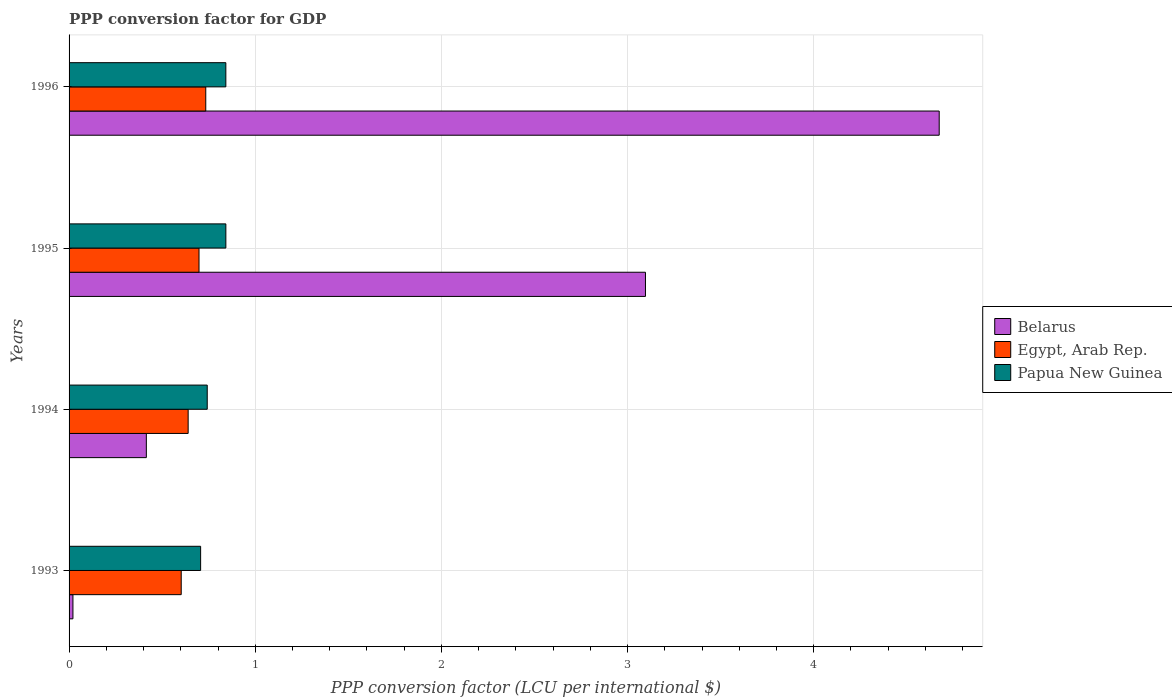How many different coloured bars are there?
Give a very brief answer. 3. How many groups of bars are there?
Keep it short and to the point. 4. Are the number of bars on each tick of the Y-axis equal?
Make the answer very short. Yes. What is the PPP conversion factor for GDP in Egypt, Arab Rep. in 1996?
Provide a short and direct response. 0.73. Across all years, what is the maximum PPP conversion factor for GDP in Belarus?
Give a very brief answer. 4.67. Across all years, what is the minimum PPP conversion factor for GDP in Belarus?
Give a very brief answer. 0.02. In which year was the PPP conversion factor for GDP in Belarus maximum?
Give a very brief answer. 1996. What is the total PPP conversion factor for GDP in Egypt, Arab Rep. in the graph?
Your answer should be very brief. 2.67. What is the difference between the PPP conversion factor for GDP in Egypt, Arab Rep. in 1993 and that in 1995?
Your response must be concise. -0.1. What is the difference between the PPP conversion factor for GDP in Egypt, Arab Rep. in 1993 and the PPP conversion factor for GDP in Belarus in 1996?
Provide a succinct answer. -4.07. What is the average PPP conversion factor for GDP in Papua New Guinea per year?
Give a very brief answer. 0.78. In the year 1993, what is the difference between the PPP conversion factor for GDP in Belarus and PPP conversion factor for GDP in Egypt, Arab Rep.?
Ensure brevity in your answer.  -0.58. In how many years, is the PPP conversion factor for GDP in Egypt, Arab Rep. greater than 2.2 LCU?
Keep it short and to the point. 0. What is the ratio of the PPP conversion factor for GDP in Belarus in 1993 to that in 1995?
Give a very brief answer. 0.01. What is the difference between the highest and the second highest PPP conversion factor for GDP in Egypt, Arab Rep.?
Your answer should be compact. 0.04. What is the difference between the highest and the lowest PPP conversion factor for GDP in Papua New Guinea?
Provide a succinct answer. 0.14. What does the 3rd bar from the top in 1996 represents?
Keep it short and to the point. Belarus. What does the 1st bar from the bottom in 1994 represents?
Your answer should be compact. Belarus. Is it the case that in every year, the sum of the PPP conversion factor for GDP in Belarus and PPP conversion factor for GDP in Papua New Guinea is greater than the PPP conversion factor for GDP in Egypt, Arab Rep.?
Ensure brevity in your answer.  Yes. How many bars are there?
Ensure brevity in your answer.  12. Are all the bars in the graph horizontal?
Make the answer very short. Yes. How many years are there in the graph?
Offer a very short reply. 4. What is the difference between two consecutive major ticks on the X-axis?
Your answer should be compact. 1. Are the values on the major ticks of X-axis written in scientific E-notation?
Offer a very short reply. No. Does the graph contain any zero values?
Ensure brevity in your answer.  No. Does the graph contain grids?
Provide a short and direct response. Yes. Where does the legend appear in the graph?
Your answer should be compact. Center right. What is the title of the graph?
Your answer should be compact. PPP conversion factor for GDP. What is the label or title of the X-axis?
Ensure brevity in your answer.  PPP conversion factor (LCU per international $). What is the label or title of the Y-axis?
Provide a succinct answer. Years. What is the PPP conversion factor (LCU per international $) of Belarus in 1993?
Your answer should be compact. 0.02. What is the PPP conversion factor (LCU per international $) in Egypt, Arab Rep. in 1993?
Offer a terse response. 0.6. What is the PPP conversion factor (LCU per international $) in Papua New Guinea in 1993?
Give a very brief answer. 0.71. What is the PPP conversion factor (LCU per international $) of Belarus in 1994?
Ensure brevity in your answer.  0.42. What is the PPP conversion factor (LCU per international $) in Egypt, Arab Rep. in 1994?
Make the answer very short. 0.64. What is the PPP conversion factor (LCU per international $) of Papua New Guinea in 1994?
Provide a short and direct response. 0.74. What is the PPP conversion factor (LCU per international $) in Belarus in 1995?
Ensure brevity in your answer.  3.1. What is the PPP conversion factor (LCU per international $) in Egypt, Arab Rep. in 1995?
Provide a short and direct response. 0.7. What is the PPP conversion factor (LCU per international $) of Papua New Guinea in 1995?
Provide a short and direct response. 0.84. What is the PPP conversion factor (LCU per international $) in Belarus in 1996?
Provide a succinct answer. 4.67. What is the PPP conversion factor (LCU per international $) of Egypt, Arab Rep. in 1996?
Provide a short and direct response. 0.73. What is the PPP conversion factor (LCU per international $) of Papua New Guinea in 1996?
Your answer should be compact. 0.84. Across all years, what is the maximum PPP conversion factor (LCU per international $) in Belarus?
Keep it short and to the point. 4.67. Across all years, what is the maximum PPP conversion factor (LCU per international $) in Egypt, Arab Rep.?
Provide a succinct answer. 0.73. Across all years, what is the maximum PPP conversion factor (LCU per international $) in Papua New Guinea?
Your answer should be very brief. 0.84. Across all years, what is the minimum PPP conversion factor (LCU per international $) in Belarus?
Give a very brief answer. 0.02. Across all years, what is the minimum PPP conversion factor (LCU per international $) of Egypt, Arab Rep.?
Your answer should be very brief. 0.6. Across all years, what is the minimum PPP conversion factor (LCU per international $) in Papua New Guinea?
Ensure brevity in your answer.  0.71. What is the total PPP conversion factor (LCU per international $) in Belarus in the graph?
Provide a short and direct response. 8.21. What is the total PPP conversion factor (LCU per international $) in Egypt, Arab Rep. in the graph?
Your answer should be compact. 2.67. What is the total PPP conversion factor (LCU per international $) of Papua New Guinea in the graph?
Your answer should be compact. 3.13. What is the difference between the PPP conversion factor (LCU per international $) of Belarus in 1993 and that in 1994?
Your answer should be very brief. -0.39. What is the difference between the PPP conversion factor (LCU per international $) of Egypt, Arab Rep. in 1993 and that in 1994?
Your answer should be very brief. -0.04. What is the difference between the PPP conversion factor (LCU per international $) of Papua New Guinea in 1993 and that in 1994?
Your answer should be very brief. -0.04. What is the difference between the PPP conversion factor (LCU per international $) in Belarus in 1993 and that in 1995?
Give a very brief answer. -3.08. What is the difference between the PPP conversion factor (LCU per international $) in Egypt, Arab Rep. in 1993 and that in 1995?
Offer a very short reply. -0.1. What is the difference between the PPP conversion factor (LCU per international $) of Papua New Guinea in 1993 and that in 1995?
Your response must be concise. -0.14. What is the difference between the PPP conversion factor (LCU per international $) of Belarus in 1993 and that in 1996?
Your answer should be compact. -4.65. What is the difference between the PPP conversion factor (LCU per international $) in Egypt, Arab Rep. in 1993 and that in 1996?
Your answer should be compact. -0.13. What is the difference between the PPP conversion factor (LCU per international $) in Papua New Guinea in 1993 and that in 1996?
Give a very brief answer. -0.14. What is the difference between the PPP conversion factor (LCU per international $) in Belarus in 1994 and that in 1995?
Make the answer very short. -2.68. What is the difference between the PPP conversion factor (LCU per international $) of Egypt, Arab Rep. in 1994 and that in 1995?
Offer a terse response. -0.06. What is the difference between the PPP conversion factor (LCU per international $) of Papua New Guinea in 1994 and that in 1995?
Ensure brevity in your answer.  -0.1. What is the difference between the PPP conversion factor (LCU per international $) of Belarus in 1994 and that in 1996?
Your answer should be compact. -4.26. What is the difference between the PPP conversion factor (LCU per international $) in Egypt, Arab Rep. in 1994 and that in 1996?
Your answer should be compact. -0.09. What is the difference between the PPP conversion factor (LCU per international $) of Belarus in 1995 and that in 1996?
Provide a succinct answer. -1.58. What is the difference between the PPP conversion factor (LCU per international $) of Egypt, Arab Rep. in 1995 and that in 1996?
Provide a short and direct response. -0.04. What is the difference between the PPP conversion factor (LCU per international $) in Belarus in 1993 and the PPP conversion factor (LCU per international $) in Egypt, Arab Rep. in 1994?
Give a very brief answer. -0.62. What is the difference between the PPP conversion factor (LCU per international $) in Belarus in 1993 and the PPP conversion factor (LCU per international $) in Papua New Guinea in 1994?
Keep it short and to the point. -0.72. What is the difference between the PPP conversion factor (LCU per international $) in Egypt, Arab Rep. in 1993 and the PPP conversion factor (LCU per international $) in Papua New Guinea in 1994?
Your answer should be very brief. -0.14. What is the difference between the PPP conversion factor (LCU per international $) in Belarus in 1993 and the PPP conversion factor (LCU per international $) in Egypt, Arab Rep. in 1995?
Ensure brevity in your answer.  -0.68. What is the difference between the PPP conversion factor (LCU per international $) in Belarus in 1993 and the PPP conversion factor (LCU per international $) in Papua New Guinea in 1995?
Your response must be concise. -0.82. What is the difference between the PPP conversion factor (LCU per international $) of Egypt, Arab Rep. in 1993 and the PPP conversion factor (LCU per international $) of Papua New Guinea in 1995?
Your response must be concise. -0.24. What is the difference between the PPP conversion factor (LCU per international $) in Belarus in 1993 and the PPP conversion factor (LCU per international $) in Egypt, Arab Rep. in 1996?
Your answer should be very brief. -0.71. What is the difference between the PPP conversion factor (LCU per international $) of Belarus in 1993 and the PPP conversion factor (LCU per international $) of Papua New Guinea in 1996?
Give a very brief answer. -0.82. What is the difference between the PPP conversion factor (LCU per international $) in Egypt, Arab Rep. in 1993 and the PPP conversion factor (LCU per international $) in Papua New Guinea in 1996?
Ensure brevity in your answer.  -0.24. What is the difference between the PPP conversion factor (LCU per international $) in Belarus in 1994 and the PPP conversion factor (LCU per international $) in Egypt, Arab Rep. in 1995?
Give a very brief answer. -0.28. What is the difference between the PPP conversion factor (LCU per international $) of Belarus in 1994 and the PPP conversion factor (LCU per international $) of Papua New Guinea in 1995?
Your answer should be very brief. -0.43. What is the difference between the PPP conversion factor (LCU per international $) of Egypt, Arab Rep. in 1994 and the PPP conversion factor (LCU per international $) of Papua New Guinea in 1995?
Your answer should be very brief. -0.2. What is the difference between the PPP conversion factor (LCU per international $) in Belarus in 1994 and the PPP conversion factor (LCU per international $) in Egypt, Arab Rep. in 1996?
Offer a terse response. -0.32. What is the difference between the PPP conversion factor (LCU per international $) in Belarus in 1994 and the PPP conversion factor (LCU per international $) in Papua New Guinea in 1996?
Offer a terse response. -0.43. What is the difference between the PPP conversion factor (LCU per international $) in Egypt, Arab Rep. in 1994 and the PPP conversion factor (LCU per international $) in Papua New Guinea in 1996?
Give a very brief answer. -0.2. What is the difference between the PPP conversion factor (LCU per international $) in Belarus in 1995 and the PPP conversion factor (LCU per international $) in Egypt, Arab Rep. in 1996?
Your response must be concise. 2.36. What is the difference between the PPP conversion factor (LCU per international $) in Belarus in 1995 and the PPP conversion factor (LCU per international $) in Papua New Guinea in 1996?
Keep it short and to the point. 2.25. What is the difference between the PPP conversion factor (LCU per international $) in Egypt, Arab Rep. in 1995 and the PPP conversion factor (LCU per international $) in Papua New Guinea in 1996?
Your answer should be compact. -0.14. What is the average PPP conversion factor (LCU per international $) of Belarus per year?
Give a very brief answer. 2.05. What is the average PPP conversion factor (LCU per international $) of Egypt, Arab Rep. per year?
Your answer should be compact. 0.67. What is the average PPP conversion factor (LCU per international $) of Papua New Guinea per year?
Your answer should be very brief. 0.78. In the year 1993, what is the difference between the PPP conversion factor (LCU per international $) of Belarus and PPP conversion factor (LCU per international $) of Egypt, Arab Rep.?
Give a very brief answer. -0.58. In the year 1993, what is the difference between the PPP conversion factor (LCU per international $) in Belarus and PPP conversion factor (LCU per international $) in Papua New Guinea?
Provide a short and direct response. -0.69. In the year 1993, what is the difference between the PPP conversion factor (LCU per international $) of Egypt, Arab Rep. and PPP conversion factor (LCU per international $) of Papua New Guinea?
Provide a short and direct response. -0.1. In the year 1994, what is the difference between the PPP conversion factor (LCU per international $) of Belarus and PPP conversion factor (LCU per international $) of Egypt, Arab Rep.?
Ensure brevity in your answer.  -0.22. In the year 1994, what is the difference between the PPP conversion factor (LCU per international $) in Belarus and PPP conversion factor (LCU per international $) in Papua New Guinea?
Provide a succinct answer. -0.33. In the year 1994, what is the difference between the PPP conversion factor (LCU per international $) in Egypt, Arab Rep. and PPP conversion factor (LCU per international $) in Papua New Guinea?
Your answer should be very brief. -0.1. In the year 1995, what is the difference between the PPP conversion factor (LCU per international $) of Belarus and PPP conversion factor (LCU per international $) of Egypt, Arab Rep.?
Your answer should be compact. 2.4. In the year 1995, what is the difference between the PPP conversion factor (LCU per international $) in Belarus and PPP conversion factor (LCU per international $) in Papua New Guinea?
Your response must be concise. 2.25. In the year 1995, what is the difference between the PPP conversion factor (LCU per international $) of Egypt, Arab Rep. and PPP conversion factor (LCU per international $) of Papua New Guinea?
Your answer should be compact. -0.14. In the year 1996, what is the difference between the PPP conversion factor (LCU per international $) of Belarus and PPP conversion factor (LCU per international $) of Egypt, Arab Rep.?
Your answer should be very brief. 3.94. In the year 1996, what is the difference between the PPP conversion factor (LCU per international $) of Belarus and PPP conversion factor (LCU per international $) of Papua New Guinea?
Your response must be concise. 3.83. In the year 1996, what is the difference between the PPP conversion factor (LCU per international $) of Egypt, Arab Rep. and PPP conversion factor (LCU per international $) of Papua New Guinea?
Your answer should be compact. -0.11. What is the ratio of the PPP conversion factor (LCU per international $) in Belarus in 1993 to that in 1994?
Give a very brief answer. 0.05. What is the ratio of the PPP conversion factor (LCU per international $) in Egypt, Arab Rep. in 1993 to that in 1994?
Keep it short and to the point. 0.94. What is the ratio of the PPP conversion factor (LCU per international $) in Papua New Guinea in 1993 to that in 1994?
Make the answer very short. 0.95. What is the ratio of the PPP conversion factor (LCU per international $) in Belarus in 1993 to that in 1995?
Offer a terse response. 0.01. What is the ratio of the PPP conversion factor (LCU per international $) in Egypt, Arab Rep. in 1993 to that in 1995?
Offer a terse response. 0.86. What is the ratio of the PPP conversion factor (LCU per international $) in Papua New Guinea in 1993 to that in 1995?
Your answer should be compact. 0.84. What is the ratio of the PPP conversion factor (LCU per international $) of Belarus in 1993 to that in 1996?
Your answer should be compact. 0. What is the ratio of the PPP conversion factor (LCU per international $) in Egypt, Arab Rep. in 1993 to that in 1996?
Offer a very short reply. 0.82. What is the ratio of the PPP conversion factor (LCU per international $) in Papua New Guinea in 1993 to that in 1996?
Offer a terse response. 0.84. What is the ratio of the PPP conversion factor (LCU per international $) of Belarus in 1994 to that in 1995?
Provide a short and direct response. 0.13. What is the ratio of the PPP conversion factor (LCU per international $) in Egypt, Arab Rep. in 1994 to that in 1995?
Give a very brief answer. 0.92. What is the ratio of the PPP conversion factor (LCU per international $) of Papua New Guinea in 1994 to that in 1995?
Your response must be concise. 0.88. What is the ratio of the PPP conversion factor (LCU per international $) of Belarus in 1994 to that in 1996?
Ensure brevity in your answer.  0.09. What is the ratio of the PPP conversion factor (LCU per international $) of Egypt, Arab Rep. in 1994 to that in 1996?
Provide a short and direct response. 0.87. What is the ratio of the PPP conversion factor (LCU per international $) in Papua New Guinea in 1994 to that in 1996?
Give a very brief answer. 0.88. What is the ratio of the PPP conversion factor (LCU per international $) of Belarus in 1995 to that in 1996?
Ensure brevity in your answer.  0.66. What is the ratio of the PPP conversion factor (LCU per international $) of Egypt, Arab Rep. in 1995 to that in 1996?
Your response must be concise. 0.95. What is the difference between the highest and the second highest PPP conversion factor (LCU per international $) of Belarus?
Your answer should be very brief. 1.58. What is the difference between the highest and the second highest PPP conversion factor (LCU per international $) in Egypt, Arab Rep.?
Offer a very short reply. 0.04. What is the difference between the highest and the lowest PPP conversion factor (LCU per international $) of Belarus?
Make the answer very short. 4.65. What is the difference between the highest and the lowest PPP conversion factor (LCU per international $) in Egypt, Arab Rep.?
Offer a very short reply. 0.13. What is the difference between the highest and the lowest PPP conversion factor (LCU per international $) of Papua New Guinea?
Keep it short and to the point. 0.14. 